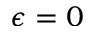Convert formula to latex. <formula><loc_0><loc_0><loc_500><loc_500>\epsilon = 0</formula> 